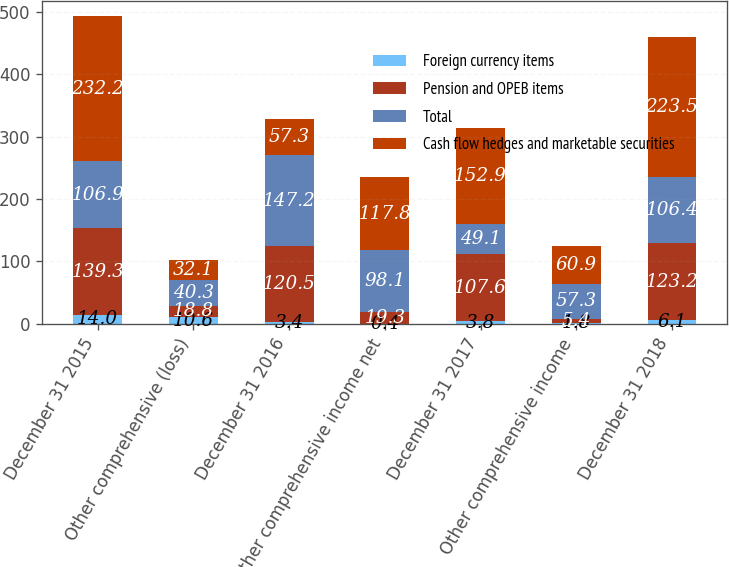<chart> <loc_0><loc_0><loc_500><loc_500><stacked_bar_chart><ecel><fcel>December 31 2015<fcel>Other comprehensive (loss)<fcel>December 31 2016<fcel>Other comprehensive income net<fcel>December 31 2017<fcel>Other comprehensive income<fcel>December 31 2018<nl><fcel>Foreign currency items<fcel>14<fcel>10.6<fcel>3.4<fcel>0.4<fcel>3.8<fcel>1.8<fcel>6.1<nl><fcel>Pension and OPEB items<fcel>139.3<fcel>18.8<fcel>120.5<fcel>19.3<fcel>107.6<fcel>5.4<fcel>123.2<nl><fcel>Total<fcel>106.9<fcel>40.3<fcel>147.2<fcel>98.1<fcel>49.1<fcel>57.3<fcel>106.4<nl><fcel>Cash flow hedges and marketable securities<fcel>232.2<fcel>32.1<fcel>57.3<fcel>117.8<fcel>152.9<fcel>60.9<fcel>223.5<nl></chart> 